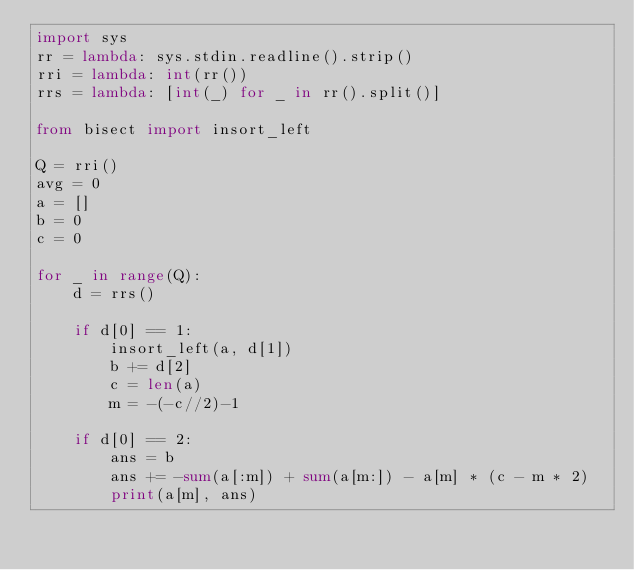Convert code to text. <code><loc_0><loc_0><loc_500><loc_500><_Python_>import sys
rr = lambda: sys.stdin.readline().strip()
rri = lambda: int(rr())
rrs = lambda: [int(_) for _ in rr().split()]

from bisect import insort_left

Q = rri()
avg = 0
a = []
b = 0
c = 0

for _ in range(Q):
    d = rrs()

    if d[0] == 1:
        insort_left(a, d[1])
        b += d[2]
        c = len(a)
        m = -(-c//2)-1
    
    if d[0] == 2:
        ans = b
        ans += -sum(a[:m]) + sum(a[m:]) - a[m] * (c - m * 2)
        print(a[m], ans)
</code> 